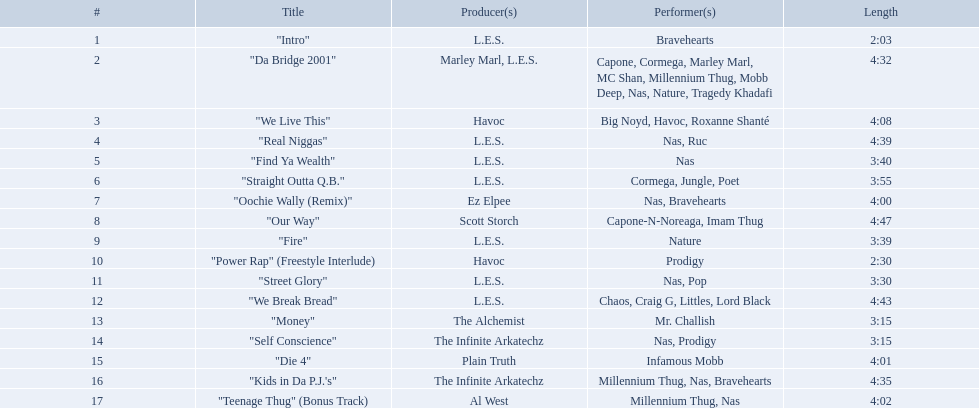What are all the songs on the album? "Intro", "Da Bridge 2001", "We Live This", "Real Niggas", "Find Ya Wealth", "Straight Outta Q.B.", "Oochie Wally (Remix)", "Our Way", "Fire", "Power Rap" (Freestyle Interlude), "Street Glory", "We Break Bread", "Money", "Self Conscience", "Die 4", "Kids in Da P.J.'s", "Teenage Thug" (Bonus Track). Which is the shortest? "Intro". How long is that song? 2:03. What are the track lengths on the album? 2:03, 4:32, 4:08, 4:39, 3:40, 3:55, 4:00, 4:47, 3:39, 2:30, 3:30, 4:43, 3:15, 3:15, 4:01, 4:35, 4:02. What is the longest length? 4:47. What is the length of each melody? 2:03, 4:32, 4:08, 4:39, 3:40, 3:55, 4:00, 4:47, 3:39, 2:30, 3:30, 4:43, 3:15, 3:15, 4:01, 4:35, 4:02. From them, which one has the shortest span? 2:03. What are all the titles of the songs? "Intro", "Da Bridge 2001", "We Live This", "Real Niggas", "Find Ya Wealth", "Straight Outta Q.B.", "Oochie Wally (Remix)", "Our Way", "Fire", "Power Rap" (Freestyle Interlude), "Street Glory", "We Break Bread", "Money", "Self Conscience", "Die 4", "Kids in Da P.J.'s", "Teenage Thug" (Bonus Track). Who produced each of these tracks? L.E.S., Marley Marl, L.E.S., Ez Elpee, Scott Storch, Havoc, The Alchemist, The Infinite Arkatechz, Plain Truth, Al West. From the producers, who was behind the shortest composition? L.E.S. How short was the song this producer created? 2:03. How lengthy is each tune? 2:03, 4:32, 4:08, 4:39, 3:40, 3:55, 4:00, 4:47, 3:39, 2:30, 3:30, 4:43, 3:15, 3:15, 4:01, 4:35, 4:02. Out of those, which one has the minimum length? 2:03. Could you parse the entire table? {'header': ['#', 'Title', 'Producer(s)', 'Performer(s)', 'Length'], 'rows': [['1', '"Intro"', 'L.E.S.', 'Bravehearts', '2:03'], ['2', '"Da Bridge 2001"', 'Marley Marl, L.E.S.', 'Capone, Cormega, Marley Marl, MC Shan, Millennium Thug, Mobb Deep, Nas, Nature, Tragedy Khadafi', '4:32'], ['3', '"We Live This"', 'Havoc', 'Big Noyd, Havoc, Roxanne Shanté', '4:08'], ['4', '"Real Niggas"', 'L.E.S.', 'Nas, Ruc', '4:39'], ['5', '"Find Ya Wealth"', 'L.E.S.', 'Nas', '3:40'], ['6', '"Straight Outta Q.B."', 'L.E.S.', 'Cormega, Jungle, Poet', '3:55'], ['7', '"Oochie Wally (Remix)"', 'Ez Elpee', 'Nas, Bravehearts', '4:00'], ['8', '"Our Way"', 'Scott Storch', 'Capone-N-Noreaga, Imam Thug', '4:47'], ['9', '"Fire"', 'L.E.S.', 'Nature', '3:39'], ['10', '"Power Rap" (Freestyle Interlude)', 'Havoc', 'Prodigy', '2:30'], ['11', '"Street Glory"', 'L.E.S.', 'Nas, Pop', '3:30'], ['12', '"We Break Bread"', 'L.E.S.', 'Chaos, Craig G, Littles, Lord Black', '4:43'], ['13', '"Money"', 'The Alchemist', 'Mr. Challish', '3:15'], ['14', '"Self Conscience"', 'The Infinite Arkatechz', 'Nas, Prodigy', '3:15'], ['15', '"Die 4"', 'Plain Truth', 'Infamous Mobb', '4:01'], ['16', '"Kids in Da P.J.\'s"', 'The Infinite Arkatechz', 'Millennium Thug, Nas, Bravehearts', '4:35'], ['17', '"Teenage Thug" (Bonus Track)', 'Al West', 'Millennium Thug, Nas', '4:02']]} Can you provide a list of all the song titles? "Intro", "Da Bridge 2001", "We Live This", "Real Niggas", "Find Ya Wealth", "Straight Outta Q.B.", "Oochie Wally (Remix)", "Our Way", "Fire", "Power Rap" (Freestyle Interlude), "Street Glory", "We Break Bread", "Money", "Self Conscience", "Die 4", "Kids in Da P.J.'s", "Teenage Thug" (Bonus Track). Who were the producers for these songs? L.E.S., Marley Marl, L.E.S., Ez Elpee, Scott Storch, Havoc, The Alchemist, The Infinite Arkatechz, Plain Truth, Al West. Which producer made the shortest song? L.E.S. How long is the shortest song produced by this person? 2:03. What is the duration of each song? 2:03, 4:32, 4:08, 4:39, 3:40, 3:55, 4:00, 4:47, 3:39, 2:30, 3:30, 4:43, 3:15, 3:15, 4:01, 4:35, 4:02. Which song has the longest length? 4:47. 